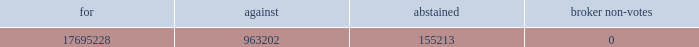Leased real property in september 2002 , we completed a sale/leaseback transaction for our 200000 square foot headquarters and manufacturing facility located in bedford , massachusetts and our 62500 square foot lorad manufacturing facility in danbury , connecticut .
The lease for these facilities , including the associated land , has a term of 20 years , with four-five year renewal options .
We sublease approximately 10000 square feet of the bedford facility to a subtenant , cmp media , under a lease which expires in may 2006 .
We also sublease approximately 11000 square feet of the bedford facility to a subtenant , genesys conferencing , under a lease which expires in february we lease a 60000 square feet of office and manufacturing space in danbury , connecticut near our lorad manufacturing facility .
This lease expires in december 2012 .
We also lease a sales and service office in belgium .
Item 3 .
Legal proceedings .
In march 2005 , we were served with a complaint filed on november 12 , 2004 by oleg sokolov with the united states district court for the district of connecticut alleging that our htc 2122 grid infringes u.s .
Patent number 5970118 .
The plaintiff is seeking to preliminarily and permanently enjoin us from infringing the patent , as well as damages resulting from the alleged infringement , treble damages and reasonable attorney fees , and such other and further relief as may be available .
On april 25 , 2005 , we filed an answer and counterclaims in response to the complaint in which we denied the plaintiff 2019s allegations and , among other things , sought declaratory relief with respect to the patent claims and damages , as well as other relief .
On october 28 , 1998 , the plaintiff had previously sued lorad , asserting , among other things , that lorad had misappropriated the plaintiff 2019s trade secrets relating to the htc grid .
This previous case was dismissed on august 28 , 2000 .
The dismissal was affirmed by the appellate court of the state of connecticut , and the united states supreme court refused to grant certiorari .
We do not believe that we infringe any valid or enforceable patents of the plaintiff .
However , while we intend to vigorously defend our interests , ongoing litigation can be costly and time consuming , and we cannot guarantee that we will prevail .
Item 4 .
Submission of matters to a vote of security holders .
At a special meeting of stockholders held november 15 , 2005 , our stockholders approved a proposal to amend our certificate of incorporation to increase the number of shares of common stock the company has authority to issue from 30 million to 90 million .
The voting results for the proposal , not adjusted for the effect of the stock split , were as follows: .
As a result of the amendment , the previously announced two-for-one stock split to be effected as a stock dividend , was paid on november 30 , 2005 to stockholders of record on november 16 , 2005. .
What portion of the votes support the proposal? 
Computations: divide(17695228, add(table_sum(17695228, 963202), 155213))
Answer: 13.89356. 